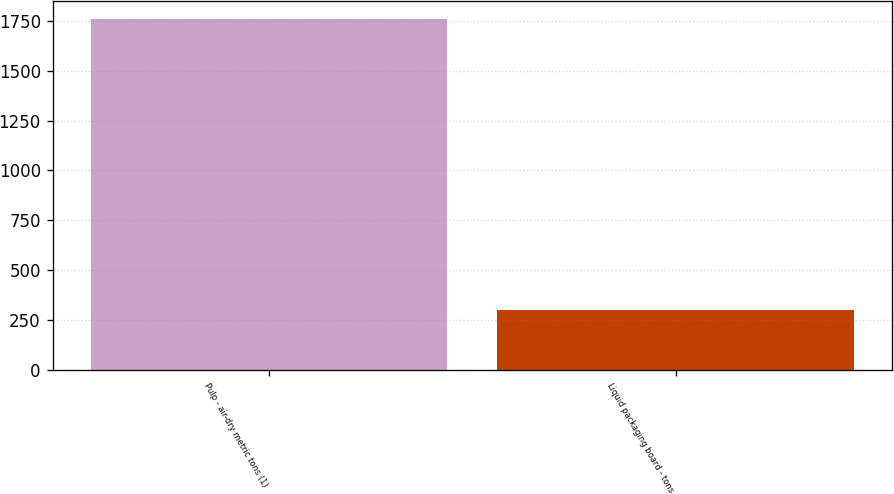Convert chart to OTSL. <chart><loc_0><loc_0><loc_500><loc_500><bar_chart><fcel>Pulp - air-dry metric tons (1)<fcel>Liquid packaging board - tons<nl><fcel>1760<fcel>297<nl></chart> 